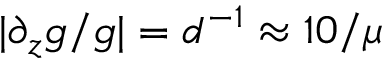<formula> <loc_0><loc_0><loc_500><loc_500>| \partial _ { z } g / g | = d ^ { - 1 } \approx 1 0 / \mu</formula> 